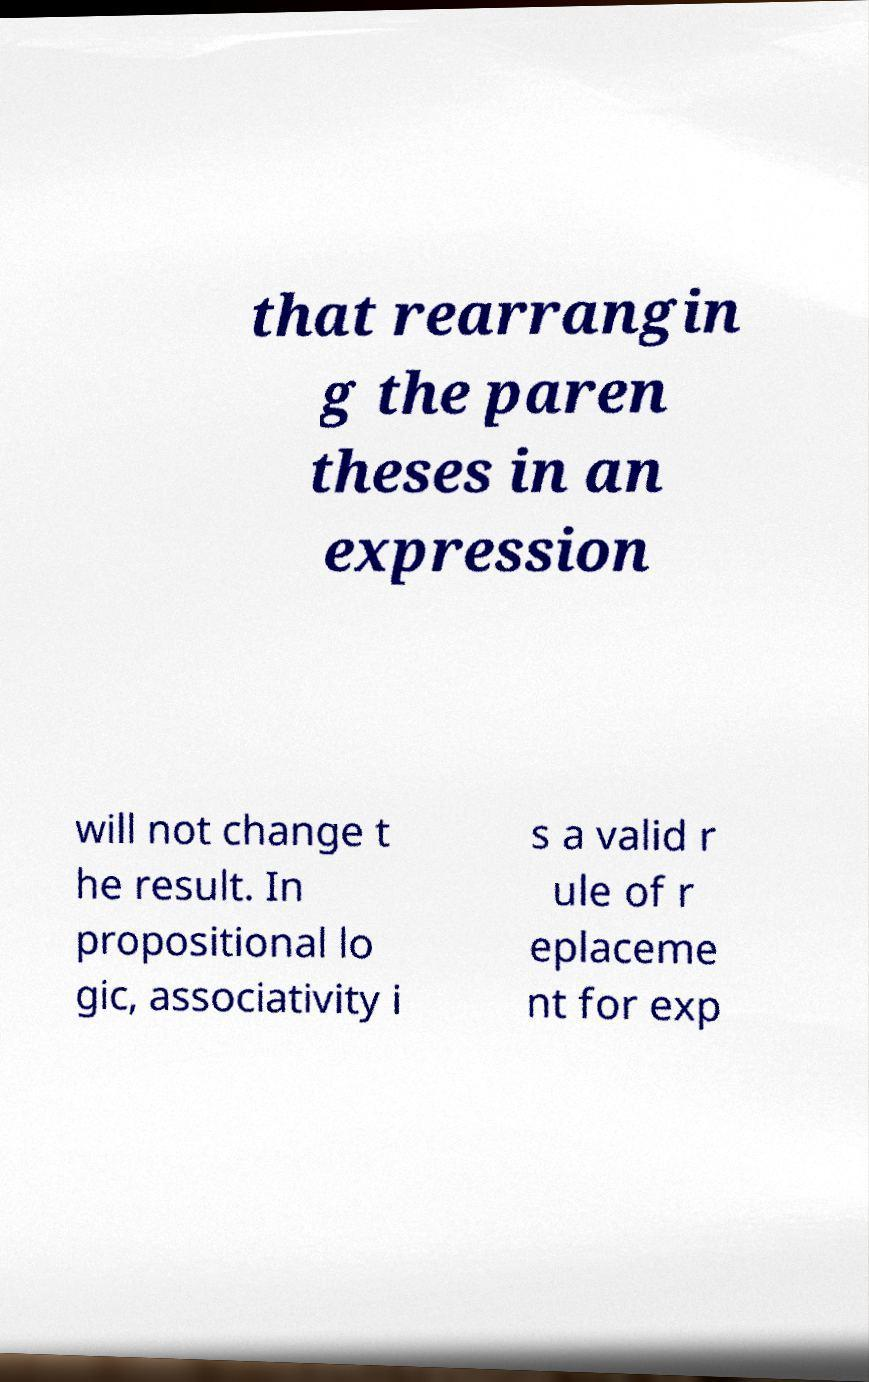Could you extract and type out the text from this image? that rearrangin g the paren theses in an expression will not change t he result. In propositional lo gic, associativity i s a valid r ule of r eplaceme nt for exp 